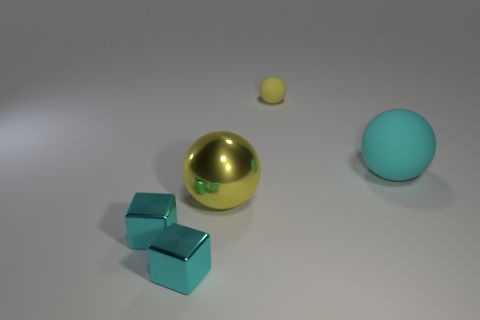How many other things are the same color as the large metallic ball?
Provide a succinct answer. 1. There is a rubber sphere to the left of the large cyan matte thing; does it have the same color as the large matte object?
Your answer should be very brief. No. Are there any tiny cyan cubes that are on the left side of the yellow metallic thing on the left side of the yellow rubber sphere?
Provide a succinct answer. Yes. There is a sphere that is both behind the big yellow shiny thing and in front of the small yellow matte thing; what material is it?
Your answer should be compact. Rubber. There is a yellow thing that is the same material as the large cyan object; what is its shape?
Make the answer very short. Sphere. Is there anything else that has the same shape as the big rubber thing?
Give a very brief answer. Yes. Do the tiny thing that is behind the yellow metallic sphere and the big cyan object have the same material?
Offer a very short reply. Yes. There is a large sphere left of the big cyan ball; what is its material?
Your response must be concise. Metal. What size is the rubber ball that is to the left of the cyan object to the right of the yellow metal object?
Your response must be concise. Small. What number of other rubber spheres have the same size as the cyan ball?
Provide a short and direct response. 0. 